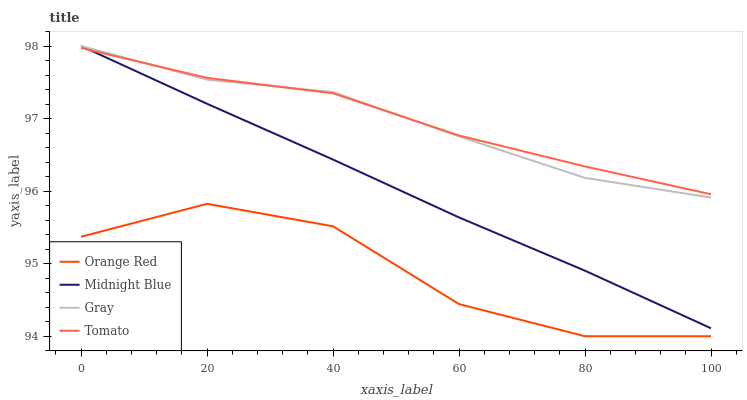Does Orange Red have the minimum area under the curve?
Answer yes or no. Yes. Does Tomato have the maximum area under the curve?
Answer yes or no. Yes. Does Gray have the minimum area under the curve?
Answer yes or no. No. Does Gray have the maximum area under the curve?
Answer yes or no. No. Is Midnight Blue the smoothest?
Answer yes or no. Yes. Is Orange Red the roughest?
Answer yes or no. Yes. Is Gray the smoothest?
Answer yes or no. No. Is Gray the roughest?
Answer yes or no. No. Does Orange Red have the lowest value?
Answer yes or no. Yes. Does Gray have the lowest value?
Answer yes or no. No. Does Midnight Blue have the highest value?
Answer yes or no. Yes. Does Orange Red have the highest value?
Answer yes or no. No. Is Orange Red less than Tomato?
Answer yes or no. Yes. Is Midnight Blue greater than Orange Red?
Answer yes or no. Yes. Does Gray intersect Tomato?
Answer yes or no. Yes. Is Gray less than Tomato?
Answer yes or no. No. Is Gray greater than Tomato?
Answer yes or no. No. Does Orange Red intersect Tomato?
Answer yes or no. No. 